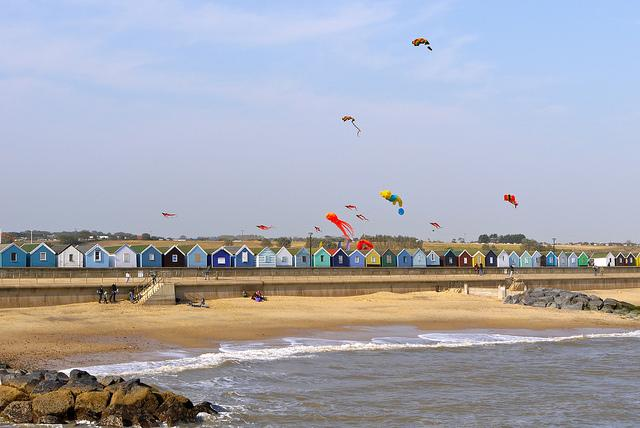Why do you need to frequently repair beach houses? hurricanes 